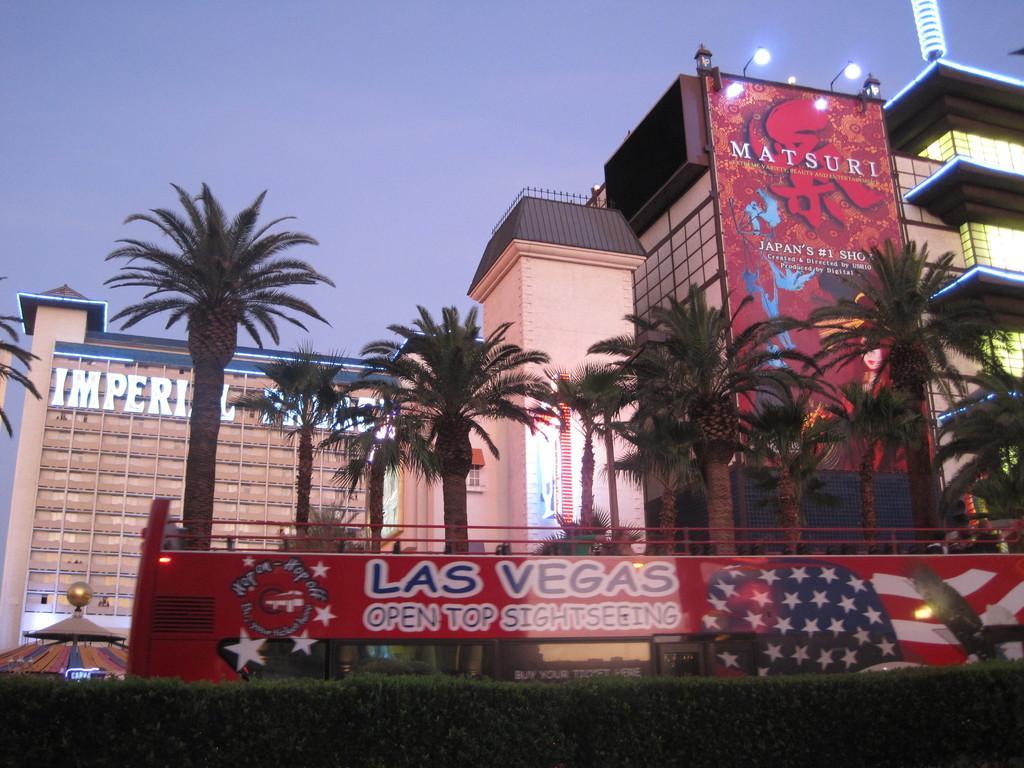Could you give a brief overview of what you see in this image? In this picture we can see buildings and trees, here we can see boards, lights and in the background we can see the sky. 